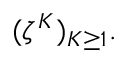<formula> <loc_0><loc_0><loc_500><loc_500>( \zeta ^ { K } ) _ { K \geq 1 } .</formula> 